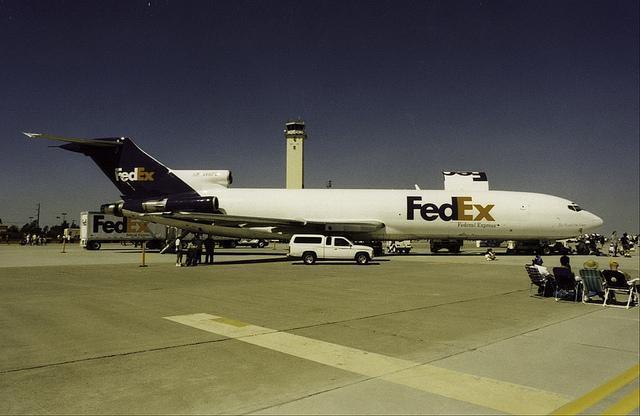How many people are sitting in lawn chairs?
Give a very brief answer. 4. How many stars are on the plane?
Give a very brief answer. 0. 